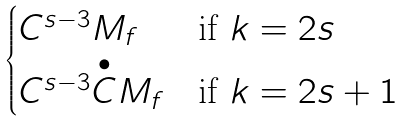<formula> <loc_0><loc_0><loc_500><loc_500>\begin{cases} C ^ { s - 3 } M _ { f } & \text {if $k=2s$} \\ C ^ { s - 3 } \overset { \bullet } { C } M _ { f } & \text {if $k=2s+1$} \end{cases}</formula> 